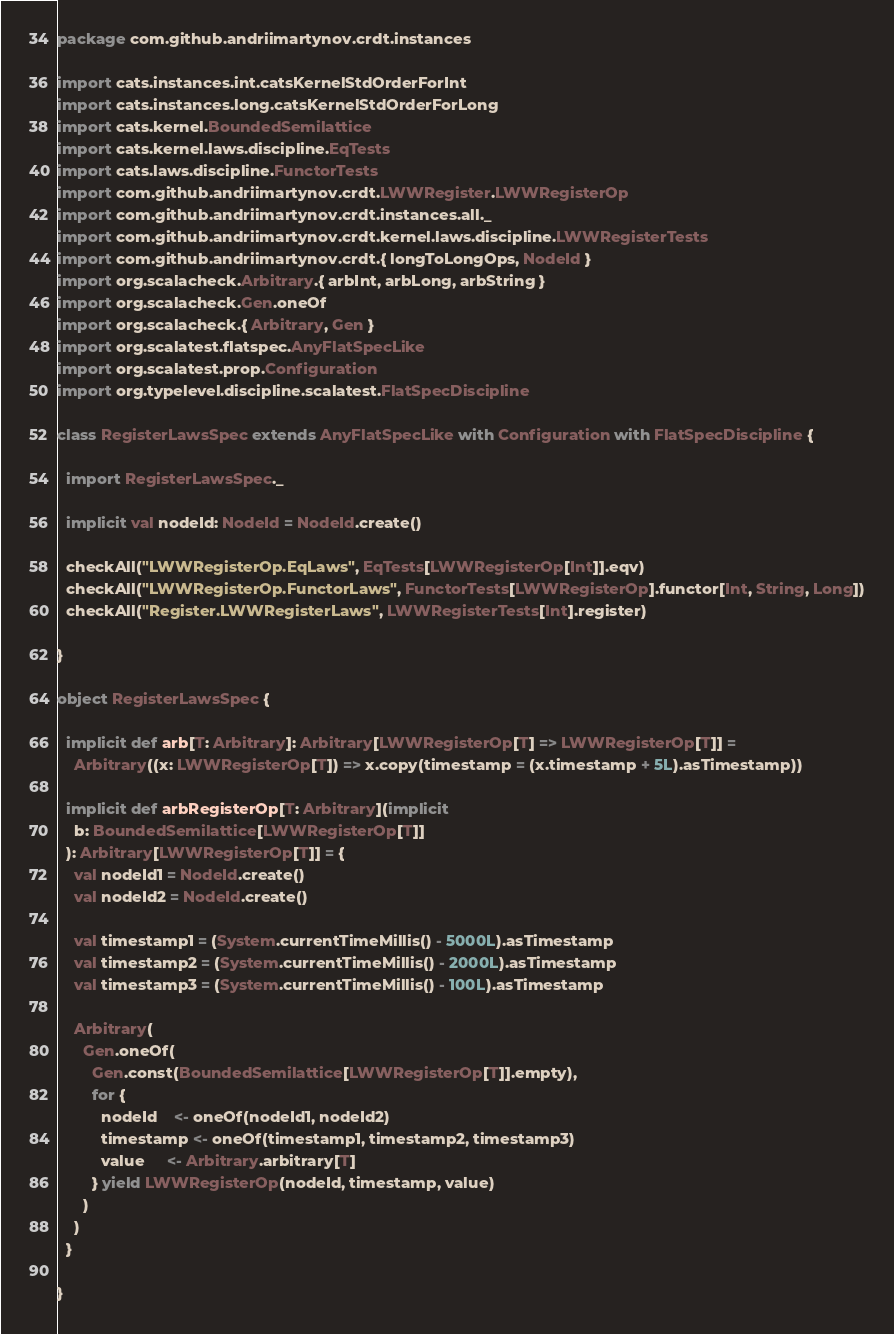<code> <loc_0><loc_0><loc_500><loc_500><_Scala_>package com.github.andriimartynov.crdt.instances

import cats.instances.int.catsKernelStdOrderForInt
import cats.instances.long.catsKernelStdOrderForLong
import cats.kernel.BoundedSemilattice
import cats.kernel.laws.discipline.EqTests
import cats.laws.discipline.FunctorTests
import com.github.andriimartynov.crdt.LWWRegister.LWWRegisterOp
import com.github.andriimartynov.crdt.instances.all._
import com.github.andriimartynov.crdt.kernel.laws.discipline.LWWRegisterTests
import com.github.andriimartynov.crdt.{ longToLongOps, NodeId }
import org.scalacheck.Arbitrary.{ arbInt, arbLong, arbString }
import org.scalacheck.Gen.oneOf
import org.scalacheck.{ Arbitrary, Gen }
import org.scalatest.flatspec.AnyFlatSpecLike
import org.scalatest.prop.Configuration
import org.typelevel.discipline.scalatest.FlatSpecDiscipline

class RegisterLawsSpec extends AnyFlatSpecLike with Configuration with FlatSpecDiscipline {

  import RegisterLawsSpec._

  implicit val nodeId: NodeId = NodeId.create()

  checkAll("LWWRegisterOp.EqLaws", EqTests[LWWRegisterOp[Int]].eqv)
  checkAll("LWWRegisterOp.FunctorLaws", FunctorTests[LWWRegisterOp].functor[Int, String, Long])
  checkAll("Register.LWWRegisterLaws", LWWRegisterTests[Int].register)

}

object RegisterLawsSpec {

  implicit def arb[T: Arbitrary]: Arbitrary[LWWRegisterOp[T] => LWWRegisterOp[T]] =
    Arbitrary((x: LWWRegisterOp[T]) => x.copy(timestamp = (x.timestamp + 5L).asTimestamp))

  implicit def arbRegisterOp[T: Arbitrary](implicit
    b: BoundedSemilattice[LWWRegisterOp[T]]
  ): Arbitrary[LWWRegisterOp[T]] = {
    val nodeId1 = NodeId.create()
    val nodeId2 = NodeId.create()

    val timestamp1 = (System.currentTimeMillis() - 5000L).asTimestamp
    val timestamp2 = (System.currentTimeMillis() - 2000L).asTimestamp
    val timestamp3 = (System.currentTimeMillis() - 100L).asTimestamp

    Arbitrary(
      Gen.oneOf(
        Gen.const(BoundedSemilattice[LWWRegisterOp[T]].empty),
        for {
          nodeId    <- oneOf(nodeId1, nodeId2)
          timestamp <- oneOf(timestamp1, timestamp2, timestamp3)
          value     <- Arbitrary.arbitrary[T]
        } yield LWWRegisterOp(nodeId, timestamp, value)
      )
    )
  }

}
</code> 